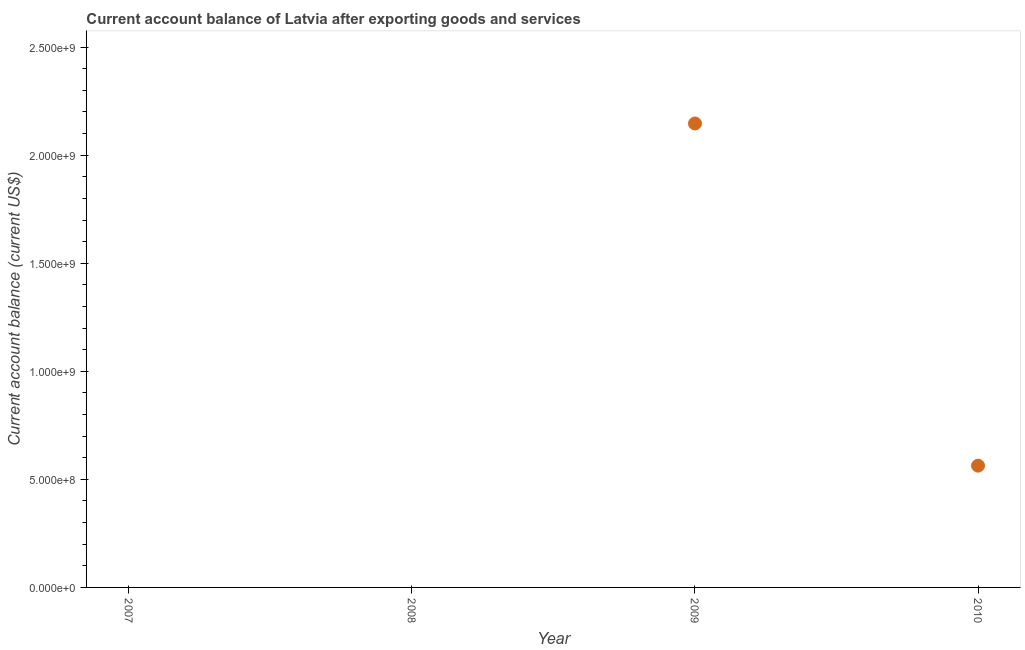What is the current account balance in 2010?
Provide a succinct answer. 5.63e+08. Across all years, what is the maximum current account balance?
Your answer should be compact. 2.15e+09. What is the sum of the current account balance?
Your answer should be very brief. 2.71e+09. What is the difference between the current account balance in 2009 and 2010?
Offer a very short reply. 1.58e+09. What is the average current account balance per year?
Provide a short and direct response. 6.77e+08. What is the median current account balance?
Offer a very short reply. 2.82e+08. In how many years, is the current account balance greater than 300000000 US$?
Offer a very short reply. 2. What is the ratio of the current account balance in 2009 to that in 2010?
Offer a terse response. 3.81. Is the current account balance in 2009 less than that in 2010?
Keep it short and to the point. No. Is the sum of the current account balance in 2009 and 2010 greater than the maximum current account balance across all years?
Your answer should be compact. Yes. What is the difference between the highest and the lowest current account balance?
Provide a short and direct response. 2.15e+09. In how many years, is the current account balance greater than the average current account balance taken over all years?
Provide a short and direct response. 1. Does the current account balance monotonically increase over the years?
Your response must be concise. No. How many years are there in the graph?
Keep it short and to the point. 4. Does the graph contain any zero values?
Offer a very short reply. Yes. What is the title of the graph?
Ensure brevity in your answer.  Current account balance of Latvia after exporting goods and services. What is the label or title of the Y-axis?
Offer a very short reply. Current account balance (current US$). What is the Current account balance (current US$) in 2008?
Keep it short and to the point. 0. What is the Current account balance (current US$) in 2009?
Provide a short and direct response. 2.15e+09. What is the Current account balance (current US$) in 2010?
Offer a terse response. 5.63e+08. What is the difference between the Current account balance (current US$) in 2009 and 2010?
Make the answer very short. 1.58e+09. What is the ratio of the Current account balance (current US$) in 2009 to that in 2010?
Keep it short and to the point. 3.81. 